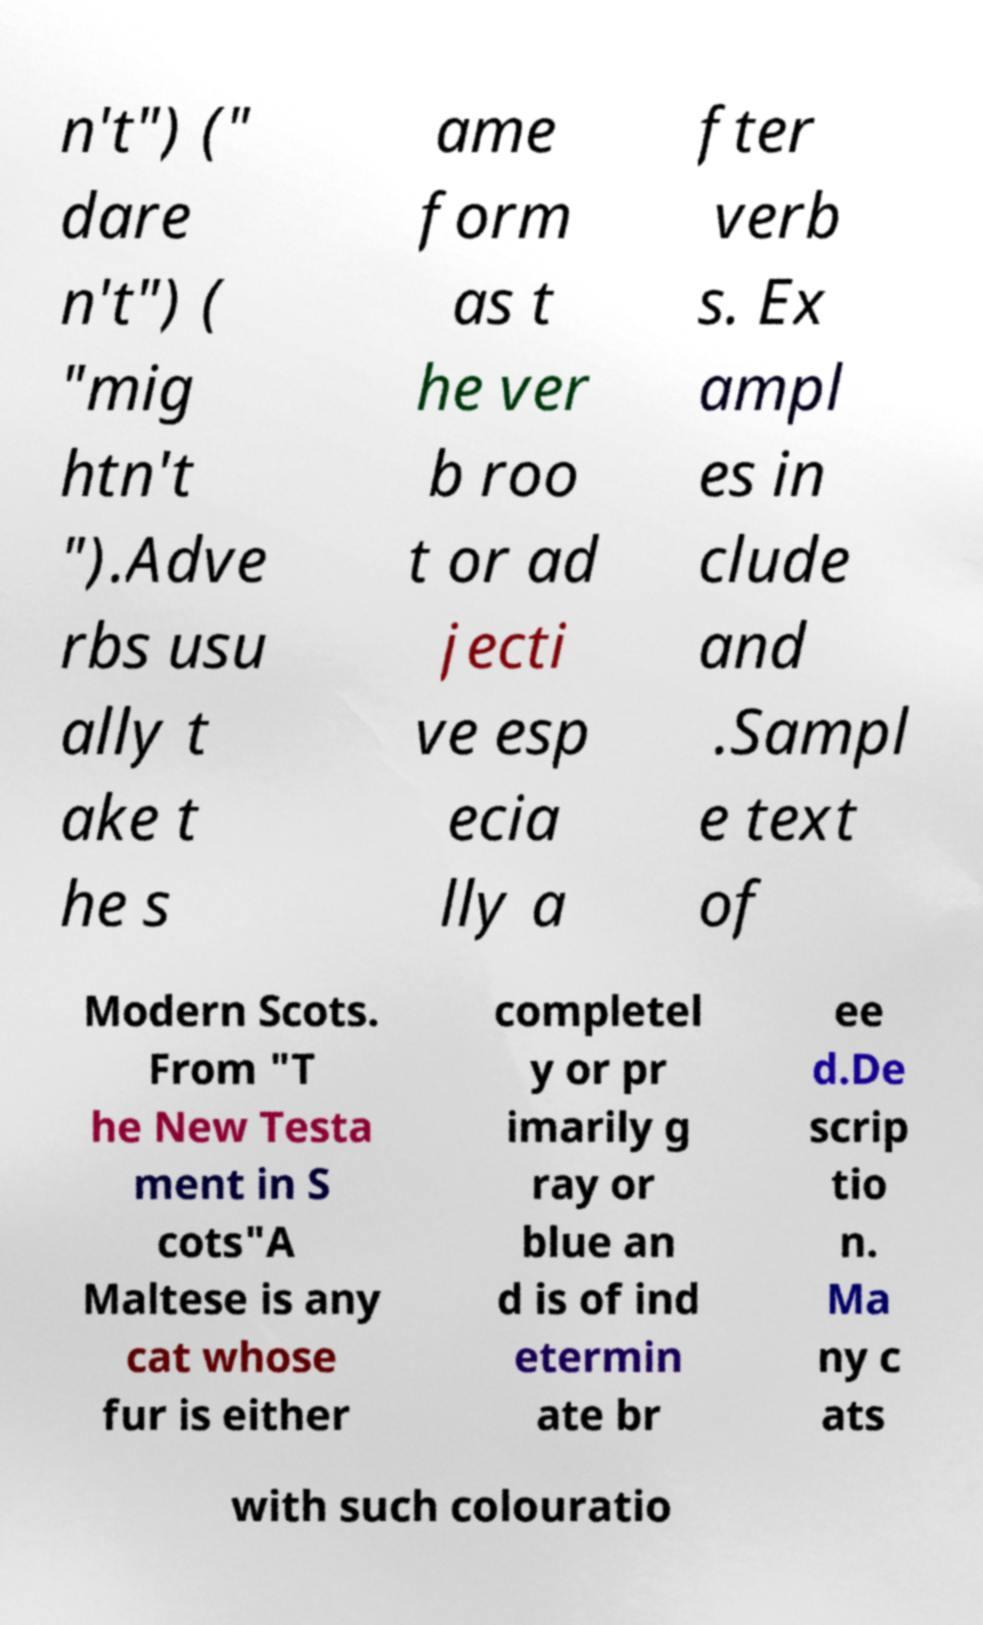I need the written content from this picture converted into text. Can you do that? n't") (" dare n't") ( "mig htn't ").Adve rbs usu ally t ake t he s ame form as t he ver b roo t or ad jecti ve esp ecia lly a fter verb s. Ex ampl es in clude and .Sampl e text of Modern Scots. From "T he New Testa ment in S cots"A Maltese is any cat whose fur is either completel y or pr imarily g ray or blue an d is of ind etermin ate br ee d.De scrip tio n. Ma ny c ats with such colouratio 